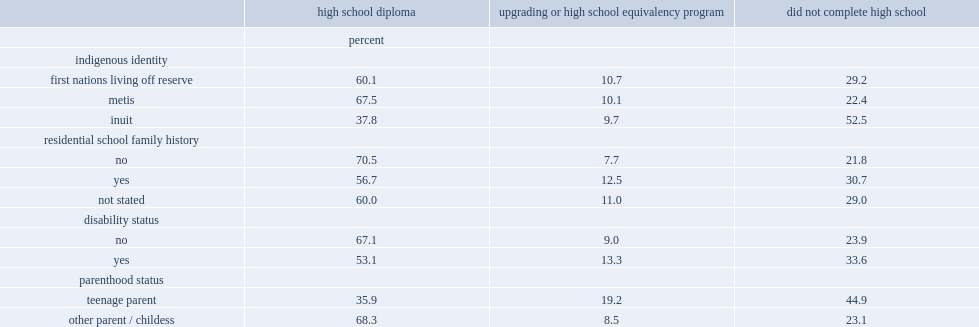How many percent of first nations people living off reserve had received a standard high school diploma? 60.1. How many percent of metis people living off reserve had received a standard high school diploma? 67.5. How many percent of inuit people living off reserve had received a standard high school diploma? 37.8. 